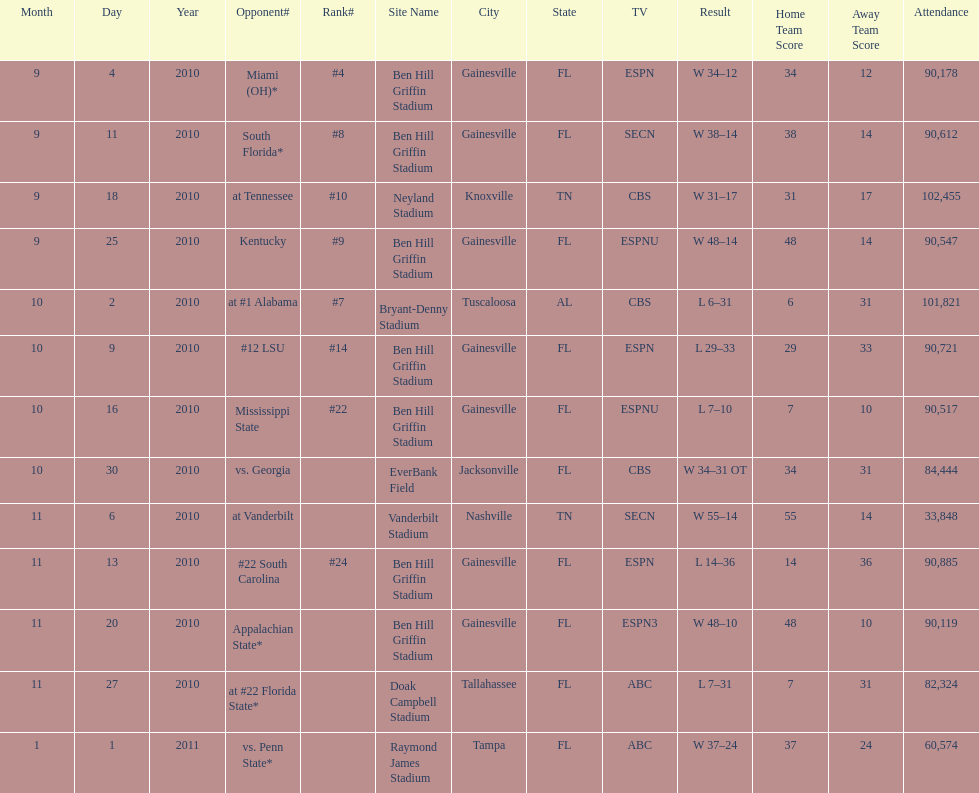What was the difference between the two scores of the last game? 13 points. 